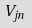<formula> <loc_0><loc_0><loc_500><loc_500>V _ { j n }</formula> 